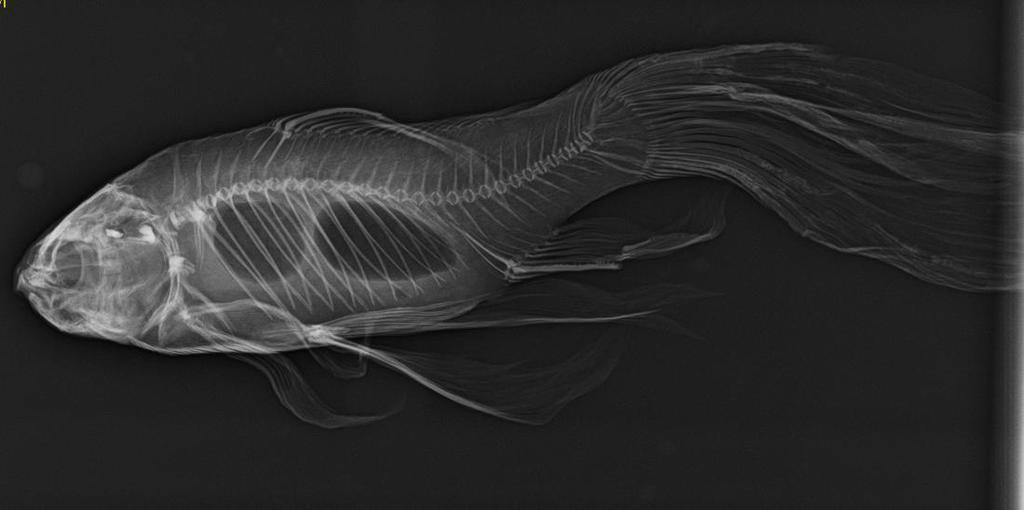What is the main subject in the foreground of the image? There is a fish skeleton in the foreground of the image. What color is the background of the image? The background of the image is black. What type of food is being prepared by the chickens in the image? There are no chickens present in the image, and therefore no food preparation can be observed. 